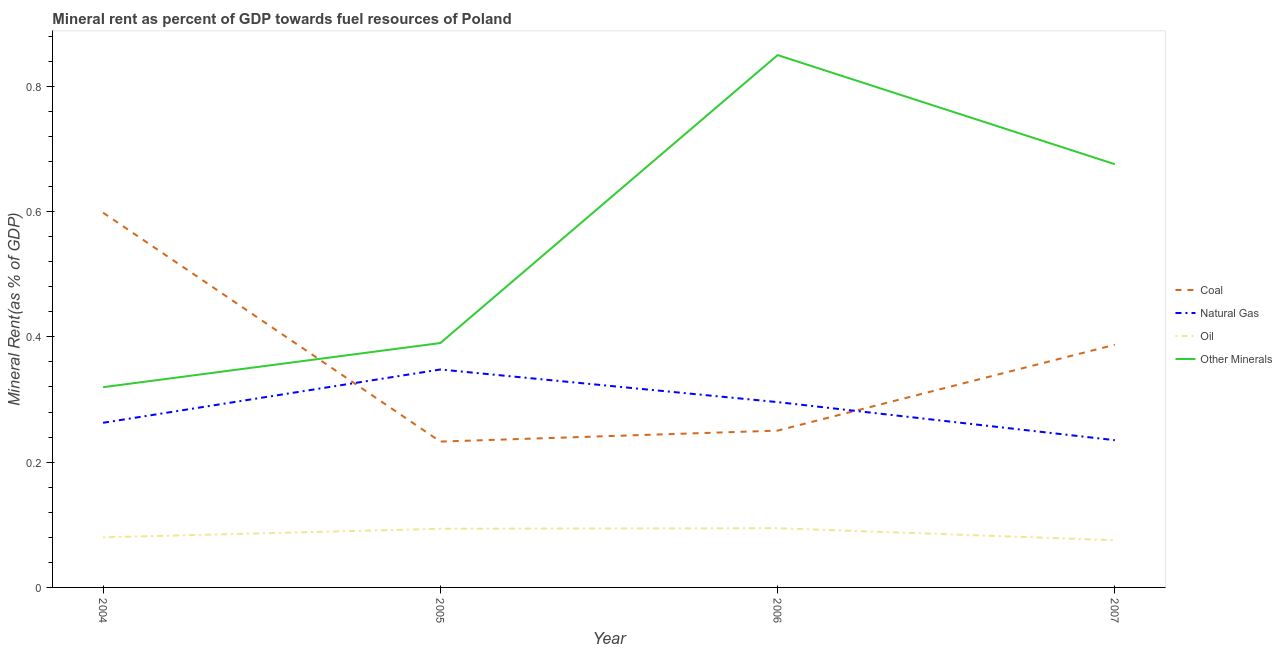How many different coloured lines are there?
Your answer should be compact. 4. Does the line corresponding to  rent of other minerals intersect with the line corresponding to coal rent?
Keep it short and to the point. Yes. Is the number of lines equal to the number of legend labels?
Provide a succinct answer. Yes. What is the  rent of other minerals in 2004?
Give a very brief answer. 0.32. Across all years, what is the maximum oil rent?
Offer a very short reply. 0.09. Across all years, what is the minimum coal rent?
Your answer should be compact. 0.23. What is the total coal rent in the graph?
Provide a short and direct response. 1.47. What is the difference between the oil rent in 2005 and that in 2007?
Your response must be concise. 0.02. What is the difference between the natural gas rent in 2007 and the  rent of other minerals in 2006?
Your answer should be compact. -0.61. What is the average natural gas rent per year?
Offer a terse response. 0.29. In the year 2004, what is the difference between the coal rent and  rent of other minerals?
Your answer should be very brief. 0.28. What is the ratio of the  rent of other minerals in 2004 to that in 2005?
Offer a terse response. 0.82. Is the oil rent in 2005 less than that in 2007?
Your response must be concise. No. Is the difference between the  rent of other minerals in 2004 and 2005 greater than the difference between the natural gas rent in 2004 and 2005?
Provide a succinct answer. Yes. What is the difference between the highest and the second highest coal rent?
Provide a succinct answer. 0.21. What is the difference between the highest and the lowest oil rent?
Ensure brevity in your answer.  0.02. In how many years, is the coal rent greater than the average coal rent taken over all years?
Your answer should be very brief. 2. Is the sum of the oil rent in 2006 and 2007 greater than the maximum  rent of other minerals across all years?
Give a very brief answer. No. Is it the case that in every year, the sum of the  rent of other minerals and oil rent is greater than the sum of coal rent and natural gas rent?
Make the answer very short. No. Is it the case that in every year, the sum of the coal rent and natural gas rent is greater than the oil rent?
Ensure brevity in your answer.  Yes. Are the values on the major ticks of Y-axis written in scientific E-notation?
Offer a terse response. No. What is the title of the graph?
Ensure brevity in your answer.  Mineral rent as percent of GDP towards fuel resources of Poland. What is the label or title of the Y-axis?
Make the answer very short. Mineral Rent(as % of GDP). What is the Mineral Rent(as % of GDP) in Coal in 2004?
Offer a terse response. 0.6. What is the Mineral Rent(as % of GDP) of Natural Gas in 2004?
Provide a short and direct response. 0.26. What is the Mineral Rent(as % of GDP) of Oil in 2004?
Ensure brevity in your answer.  0.08. What is the Mineral Rent(as % of GDP) of Other Minerals in 2004?
Offer a very short reply. 0.32. What is the Mineral Rent(as % of GDP) in Coal in 2005?
Offer a very short reply. 0.23. What is the Mineral Rent(as % of GDP) of Natural Gas in 2005?
Give a very brief answer. 0.35. What is the Mineral Rent(as % of GDP) of Oil in 2005?
Offer a very short reply. 0.09. What is the Mineral Rent(as % of GDP) of Other Minerals in 2005?
Keep it short and to the point. 0.39. What is the Mineral Rent(as % of GDP) of Coal in 2006?
Offer a terse response. 0.25. What is the Mineral Rent(as % of GDP) of Natural Gas in 2006?
Your answer should be very brief. 0.3. What is the Mineral Rent(as % of GDP) of Oil in 2006?
Ensure brevity in your answer.  0.09. What is the Mineral Rent(as % of GDP) in Other Minerals in 2006?
Your answer should be compact. 0.85. What is the Mineral Rent(as % of GDP) in Coal in 2007?
Your response must be concise. 0.39. What is the Mineral Rent(as % of GDP) of Natural Gas in 2007?
Your response must be concise. 0.24. What is the Mineral Rent(as % of GDP) of Oil in 2007?
Keep it short and to the point. 0.08. What is the Mineral Rent(as % of GDP) in Other Minerals in 2007?
Provide a short and direct response. 0.68. Across all years, what is the maximum Mineral Rent(as % of GDP) in Coal?
Ensure brevity in your answer.  0.6. Across all years, what is the maximum Mineral Rent(as % of GDP) of Natural Gas?
Provide a short and direct response. 0.35. Across all years, what is the maximum Mineral Rent(as % of GDP) in Oil?
Your response must be concise. 0.09. Across all years, what is the maximum Mineral Rent(as % of GDP) of Other Minerals?
Provide a short and direct response. 0.85. Across all years, what is the minimum Mineral Rent(as % of GDP) of Coal?
Your response must be concise. 0.23. Across all years, what is the minimum Mineral Rent(as % of GDP) in Natural Gas?
Offer a terse response. 0.24. Across all years, what is the minimum Mineral Rent(as % of GDP) of Oil?
Offer a terse response. 0.08. Across all years, what is the minimum Mineral Rent(as % of GDP) of Other Minerals?
Keep it short and to the point. 0.32. What is the total Mineral Rent(as % of GDP) of Coal in the graph?
Offer a very short reply. 1.47. What is the total Mineral Rent(as % of GDP) in Natural Gas in the graph?
Offer a very short reply. 1.14. What is the total Mineral Rent(as % of GDP) in Oil in the graph?
Keep it short and to the point. 0.34. What is the total Mineral Rent(as % of GDP) of Other Minerals in the graph?
Provide a short and direct response. 2.24. What is the difference between the Mineral Rent(as % of GDP) in Coal in 2004 and that in 2005?
Offer a very short reply. 0.37. What is the difference between the Mineral Rent(as % of GDP) of Natural Gas in 2004 and that in 2005?
Ensure brevity in your answer.  -0.09. What is the difference between the Mineral Rent(as % of GDP) of Oil in 2004 and that in 2005?
Provide a short and direct response. -0.01. What is the difference between the Mineral Rent(as % of GDP) in Other Minerals in 2004 and that in 2005?
Provide a succinct answer. -0.07. What is the difference between the Mineral Rent(as % of GDP) of Coal in 2004 and that in 2006?
Provide a succinct answer. 0.35. What is the difference between the Mineral Rent(as % of GDP) of Natural Gas in 2004 and that in 2006?
Give a very brief answer. -0.03. What is the difference between the Mineral Rent(as % of GDP) in Oil in 2004 and that in 2006?
Provide a short and direct response. -0.01. What is the difference between the Mineral Rent(as % of GDP) in Other Minerals in 2004 and that in 2006?
Your answer should be very brief. -0.53. What is the difference between the Mineral Rent(as % of GDP) in Coal in 2004 and that in 2007?
Offer a terse response. 0.21. What is the difference between the Mineral Rent(as % of GDP) of Natural Gas in 2004 and that in 2007?
Provide a succinct answer. 0.03. What is the difference between the Mineral Rent(as % of GDP) in Oil in 2004 and that in 2007?
Keep it short and to the point. 0. What is the difference between the Mineral Rent(as % of GDP) in Other Minerals in 2004 and that in 2007?
Give a very brief answer. -0.36. What is the difference between the Mineral Rent(as % of GDP) in Coal in 2005 and that in 2006?
Offer a terse response. -0.02. What is the difference between the Mineral Rent(as % of GDP) in Natural Gas in 2005 and that in 2006?
Ensure brevity in your answer.  0.05. What is the difference between the Mineral Rent(as % of GDP) of Oil in 2005 and that in 2006?
Your answer should be compact. -0. What is the difference between the Mineral Rent(as % of GDP) in Other Minerals in 2005 and that in 2006?
Make the answer very short. -0.46. What is the difference between the Mineral Rent(as % of GDP) in Coal in 2005 and that in 2007?
Keep it short and to the point. -0.15. What is the difference between the Mineral Rent(as % of GDP) in Natural Gas in 2005 and that in 2007?
Your response must be concise. 0.11. What is the difference between the Mineral Rent(as % of GDP) of Oil in 2005 and that in 2007?
Provide a short and direct response. 0.02. What is the difference between the Mineral Rent(as % of GDP) in Other Minerals in 2005 and that in 2007?
Provide a short and direct response. -0.29. What is the difference between the Mineral Rent(as % of GDP) of Coal in 2006 and that in 2007?
Give a very brief answer. -0.14. What is the difference between the Mineral Rent(as % of GDP) in Natural Gas in 2006 and that in 2007?
Offer a terse response. 0.06. What is the difference between the Mineral Rent(as % of GDP) in Oil in 2006 and that in 2007?
Your answer should be compact. 0.02. What is the difference between the Mineral Rent(as % of GDP) of Other Minerals in 2006 and that in 2007?
Your answer should be very brief. 0.17. What is the difference between the Mineral Rent(as % of GDP) in Coal in 2004 and the Mineral Rent(as % of GDP) in Natural Gas in 2005?
Provide a succinct answer. 0.25. What is the difference between the Mineral Rent(as % of GDP) in Coal in 2004 and the Mineral Rent(as % of GDP) in Oil in 2005?
Ensure brevity in your answer.  0.5. What is the difference between the Mineral Rent(as % of GDP) in Coal in 2004 and the Mineral Rent(as % of GDP) in Other Minerals in 2005?
Offer a terse response. 0.21. What is the difference between the Mineral Rent(as % of GDP) in Natural Gas in 2004 and the Mineral Rent(as % of GDP) in Oil in 2005?
Make the answer very short. 0.17. What is the difference between the Mineral Rent(as % of GDP) of Natural Gas in 2004 and the Mineral Rent(as % of GDP) of Other Minerals in 2005?
Provide a short and direct response. -0.13. What is the difference between the Mineral Rent(as % of GDP) of Oil in 2004 and the Mineral Rent(as % of GDP) of Other Minerals in 2005?
Offer a terse response. -0.31. What is the difference between the Mineral Rent(as % of GDP) in Coal in 2004 and the Mineral Rent(as % of GDP) in Natural Gas in 2006?
Provide a short and direct response. 0.3. What is the difference between the Mineral Rent(as % of GDP) of Coal in 2004 and the Mineral Rent(as % of GDP) of Oil in 2006?
Your response must be concise. 0.5. What is the difference between the Mineral Rent(as % of GDP) in Coal in 2004 and the Mineral Rent(as % of GDP) in Other Minerals in 2006?
Your response must be concise. -0.25. What is the difference between the Mineral Rent(as % of GDP) of Natural Gas in 2004 and the Mineral Rent(as % of GDP) of Oil in 2006?
Offer a terse response. 0.17. What is the difference between the Mineral Rent(as % of GDP) of Natural Gas in 2004 and the Mineral Rent(as % of GDP) of Other Minerals in 2006?
Provide a succinct answer. -0.59. What is the difference between the Mineral Rent(as % of GDP) in Oil in 2004 and the Mineral Rent(as % of GDP) in Other Minerals in 2006?
Your response must be concise. -0.77. What is the difference between the Mineral Rent(as % of GDP) in Coal in 2004 and the Mineral Rent(as % of GDP) in Natural Gas in 2007?
Your response must be concise. 0.36. What is the difference between the Mineral Rent(as % of GDP) of Coal in 2004 and the Mineral Rent(as % of GDP) of Oil in 2007?
Ensure brevity in your answer.  0.52. What is the difference between the Mineral Rent(as % of GDP) in Coal in 2004 and the Mineral Rent(as % of GDP) in Other Minerals in 2007?
Provide a succinct answer. -0.08. What is the difference between the Mineral Rent(as % of GDP) of Natural Gas in 2004 and the Mineral Rent(as % of GDP) of Oil in 2007?
Your response must be concise. 0.19. What is the difference between the Mineral Rent(as % of GDP) in Natural Gas in 2004 and the Mineral Rent(as % of GDP) in Other Minerals in 2007?
Your answer should be very brief. -0.41. What is the difference between the Mineral Rent(as % of GDP) in Oil in 2004 and the Mineral Rent(as % of GDP) in Other Minerals in 2007?
Ensure brevity in your answer.  -0.6. What is the difference between the Mineral Rent(as % of GDP) of Coal in 2005 and the Mineral Rent(as % of GDP) of Natural Gas in 2006?
Your answer should be very brief. -0.06. What is the difference between the Mineral Rent(as % of GDP) of Coal in 2005 and the Mineral Rent(as % of GDP) of Oil in 2006?
Keep it short and to the point. 0.14. What is the difference between the Mineral Rent(as % of GDP) of Coal in 2005 and the Mineral Rent(as % of GDP) of Other Minerals in 2006?
Your answer should be very brief. -0.62. What is the difference between the Mineral Rent(as % of GDP) in Natural Gas in 2005 and the Mineral Rent(as % of GDP) in Oil in 2006?
Offer a very short reply. 0.25. What is the difference between the Mineral Rent(as % of GDP) of Natural Gas in 2005 and the Mineral Rent(as % of GDP) of Other Minerals in 2006?
Your response must be concise. -0.5. What is the difference between the Mineral Rent(as % of GDP) of Oil in 2005 and the Mineral Rent(as % of GDP) of Other Minerals in 2006?
Your answer should be compact. -0.76. What is the difference between the Mineral Rent(as % of GDP) of Coal in 2005 and the Mineral Rent(as % of GDP) of Natural Gas in 2007?
Keep it short and to the point. -0. What is the difference between the Mineral Rent(as % of GDP) in Coal in 2005 and the Mineral Rent(as % of GDP) in Oil in 2007?
Your answer should be compact. 0.16. What is the difference between the Mineral Rent(as % of GDP) of Coal in 2005 and the Mineral Rent(as % of GDP) of Other Minerals in 2007?
Ensure brevity in your answer.  -0.44. What is the difference between the Mineral Rent(as % of GDP) of Natural Gas in 2005 and the Mineral Rent(as % of GDP) of Oil in 2007?
Offer a terse response. 0.27. What is the difference between the Mineral Rent(as % of GDP) in Natural Gas in 2005 and the Mineral Rent(as % of GDP) in Other Minerals in 2007?
Your answer should be compact. -0.33. What is the difference between the Mineral Rent(as % of GDP) in Oil in 2005 and the Mineral Rent(as % of GDP) in Other Minerals in 2007?
Offer a terse response. -0.58. What is the difference between the Mineral Rent(as % of GDP) of Coal in 2006 and the Mineral Rent(as % of GDP) of Natural Gas in 2007?
Keep it short and to the point. 0.02. What is the difference between the Mineral Rent(as % of GDP) in Coal in 2006 and the Mineral Rent(as % of GDP) in Oil in 2007?
Keep it short and to the point. 0.17. What is the difference between the Mineral Rent(as % of GDP) of Coal in 2006 and the Mineral Rent(as % of GDP) of Other Minerals in 2007?
Your answer should be very brief. -0.43. What is the difference between the Mineral Rent(as % of GDP) in Natural Gas in 2006 and the Mineral Rent(as % of GDP) in Oil in 2007?
Your response must be concise. 0.22. What is the difference between the Mineral Rent(as % of GDP) in Natural Gas in 2006 and the Mineral Rent(as % of GDP) in Other Minerals in 2007?
Your answer should be compact. -0.38. What is the difference between the Mineral Rent(as % of GDP) of Oil in 2006 and the Mineral Rent(as % of GDP) of Other Minerals in 2007?
Your answer should be compact. -0.58. What is the average Mineral Rent(as % of GDP) in Coal per year?
Make the answer very short. 0.37. What is the average Mineral Rent(as % of GDP) of Natural Gas per year?
Ensure brevity in your answer.  0.29. What is the average Mineral Rent(as % of GDP) in Oil per year?
Your response must be concise. 0.09. What is the average Mineral Rent(as % of GDP) in Other Minerals per year?
Your answer should be very brief. 0.56. In the year 2004, what is the difference between the Mineral Rent(as % of GDP) of Coal and Mineral Rent(as % of GDP) of Natural Gas?
Provide a succinct answer. 0.34. In the year 2004, what is the difference between the Mineral Rent(as % of GDP) of Coal and Mineral Rent(as % of GDP) of Oil?
Your response must be concise. 0.52. In the year 2004, what is the difference between the Mineral Rent(as % of GDP) in Coal and Mineral Rent(as % of GDP) in Other Minerals?
Provide a short and direct response. 0.28. In the year 2004, what is the difference between the Mineral Rent(as % of GDP) of Natural Gas and Mineral Rent(as % of GDP) of Oil?
Your answer should be compact. 0.18. In the year 2004, what is the difference between the Mineral Rent(as % of GDP) of Natural Gas and Mineral Rent(as % of GDP) of Other Minerals?
Offer a very short reply. -0.06. In the year 2004, what is the difference between the Mineral Rent(as % of GDP) in Oil and Mineral Rent(as % of GDP) in Other Minerals?
Provide a succinct answer. -0.24. In the year 2005, what is the difference between the Mineral Rent(as % of GDP) of Coal and Mineral Rent(as % of GDP) of Natural Gas?
Ensure brevity in your answer.  -0.12. In the year 2005, what is the difference between the Mineral Rent(as % of GDP) in Coal and Mineral Rent(as % of GDP) in Oil?
Offer a very short reply. 0.14. In the year 2005, what is the difference between the Mineral Rent(as % of GDP) of Coal and Mineral Rent(as % of GDP) of Other Minerals?
Offer a very short reply. -0.16. In the year 2005, what is the difference between the Mineral Rent(as % of GDP) of Natural Gas and Mineral Rent(as % of GDP) of Oil?
Offer a terse response. 0.25. In the year 2005, what is the difference between the Mineral Rent(as % of GDP) in Natural Gas and Mineral Rent(as % of GDP) in Other Minerals?
Your answer should be very brief. -0.04. In the year 2005, what is the difference between the Mineral Rent(as % of GDP) in Oil and Mineral Rent(as % of GDP) in Other Minerals?
Make the answer very short. -0.3. In the year 2006, what is the difference between the Mineral Rent(as % of GDP) in Coal and Mineral Rent(as % of GDP) in Natural Gas?
Your answer should be compact. -0.05. In the year 2006, what is the difference between the Mineral Rent(as % of GDP) in Coal and Mineral Rent(as % of GDP) in Oil?
Provide a succinct answer. 0.16. In the year 2006, what is the difference between the Mineral Rent(as % of GDP) of Coal and Mineral Rent(as % of GDP) of Other Minerals?
Offer a terse response. -0.6. In the year 2006, what is the difference between the Mineral Rent(as % of GDP) of Natural Gas and Mineral Rent(as % of GDP) of Oil?
Make the answer very short. 0.2. In the year 2006, what is the difference between the Mineral Rent(as % of GDP) in Natural Gas and Mineral Rent(as % of GDP) in Other Minerals?
Your answer should be compact. -0.55. In the year 2006, what is the difference between the Mineral Rent(as % of GDP) of Oil and Mineral Rent(as % of GDP) of Other Minerals?
Your answer should be very brief. -0.76. In the year 2007, what is the difference between the Mineral Rent(as % of GDP) in Coal and Mineral Rent(as % of GDP) in Natural Gas?
Offer a terse response. 0.15. In the year 2007, what is the difference between the Mineral Rent(as % of GDP) of Coal and Mineral Rent(as % of GDP) of Oil?
Ensure brevity in your answer.  0.31. In the year 2007, what is the difference between the Mineral Rent(as % of GDP) in Coal and Mineral Rent(as % of GDP) in Other Minerals?
Keep it short and to the point. -0.29. In the year 2007, what is the difference between the Mineral Rent(as % of GDP) of Natural Gas and Mineral Rent(as % of GDP) of Oil?
Your response must be concise. 0.16. In the year 2007, what is the difference between the Mineral Rent(as % of GDP) in Natural Gas and Mineral Rent(as % of GDP) in Other Minerals?
Keep it short and to the point. -0.44. In the year 2007, what is the difference between the Mineral Rent(as % of GDP) of Oil and Mineral Rent(as % of GDP) of Other Minerals?
Provide a succinct answer. -0.6. What is the ratio of the Mineral Rent(as % of GDP) of Coal in 2004 to that in 2005?
Provide a short and direct response. 2.57. What is the ratio of the Mineral Rent(as % of GDP) in Natural Gas in 2004 to that in 2005?
Make the answer very short. 0.76. What is the ratio of the Mineral Rent(as % of GDP) of Oil in 2004 to that in 2005?
Ensure brevity in your answer.  0.85. What is the ratio of the Mineral Rent(as % of GDP) in Other Minerals in 2004 to that in 2005?
Make the answer very short. 0.82. What is the ratio of the Mineral Rent(as % of GDP) in Coal in 2004 to that in 2006?
Your answer should be very brief. 2.39. What is the ratio of the Mineral Rent(as % of GDP) in Natural Gas in 2004 to that in 2006?
Your answer should be very brief. 0.89. What is the ratio of the Mineral Rent(as % of GDP) in Oil in 2004 to that in 2006?
Give a very brief answer. 0.85. What is the ratio of the Mineral Rent(as % of GDP) of Other Minerals in 2004 to that in 2006?
Keep it short and to the point. 0.38. What is the ratio of the Mineral Rent(as % of GDP) in Coal in 2004 to that in 2007?
Offer a terse response. 1.54. What is the ratio of the Mineral Rent(as % of GDP) in Natural Gas in 2004 to that in 2007?
Offer a terse response. 1.12. What is the ratio of the Mineral Rent(as % of GDP) in Oil in 2004 to that in 2007?
Provide a short and direct response. 1.06. What is the ratio of the Mineral Rent(as % of GDP) of Other Minerals in 2004 to that in 2007?
Provide a succinct answer. 0.47. What is the ratio of the Mineral Rent(as % of GDP) of Natural Gas in 2005 to that in 2006?
Ensure brevity in your answer.  1.18. What is the ratio of the Mineral Rent(as % of GDP) of Oil in 2005 to that in 2006?
Offer a terse response. 0.99. What is the ratio of the Mineral Rent(as % of GDP) in Other Minerals in 2005 to that in 2006?
Keep it short and to the point. 0.46. What is the ratio of the Mineral Rent(as % of GDP) of Coal in 2005 to that in 2007?
Provide a succinct answer. 0.6. What is the ratio of the Mineral Rent(as % of GDP) of Natural Gas in 2005 to that in 2007?
Your answer should be compact. 1.48. What is the ratio of the Mineral Rent(as % of GDP) in Oil in 2005 to that in 2007?
Offer a very short reply. 1.24. What is the ratio of the Mineral Rent(as % of GDP) in Other Minerals in 2005 to that in 2007?
Your answer should be compact. 0.58. What is the ratio of the Mineral Rent(as % of GDP) in Coal in 2006 to that in 2007?
Make the answer very short. 0.65. What is the ratio of the Mineral Rent(as % of GDP) of Natural Gas in 2006 to that in 2007?
Provide a short and direct response. 1.26. What is the ratio of the Mineral Rent(as % of GDP) in Oil in 2006 to that in 2007?
Provide a short and direct response. 1.25. What is the ratio of the Mineral Rent(as % of GDP) of Other Minerals in 2006 to that in 2007?
Offer a terse response. 1.26. What is the difference between the highest and the second highest Mineral Rent(as % of GDP) in Coal?
Make the answer very short. 0.21. What is the difference between the highest and the second highest Mineral Rent(as % of GDP) in Natural Gas?
Your answer should be very brief. 0.05. What is the difference between the highest and the second highest Mineral Rent(as % of GDP) of Oil?
Offer a very short reply. 0. What is the difference between the highest and the second highest Mineral Rent(as % of GDP) in Other Minerals?
Make the answer very short. 0.17. What is the difference between the highest and the lowest Mineral Rent(as % of GDP) of Coal?
Give a very brief answer. 0.37. What is the difference between the highest and the lowest Mineral Rent(as % of GDP) in Natural Gas?
Give a very brief answer. 0.11. What is the difference between the highest and the lowest Mineral Rent(as % of GDP) in Oil?
Give a very brief answer. 0.02. What is the difference between the highest and the lowest Mineral Rent(as % of GDP) of Other Minerals?
Offer a very short reply. 0.53. 